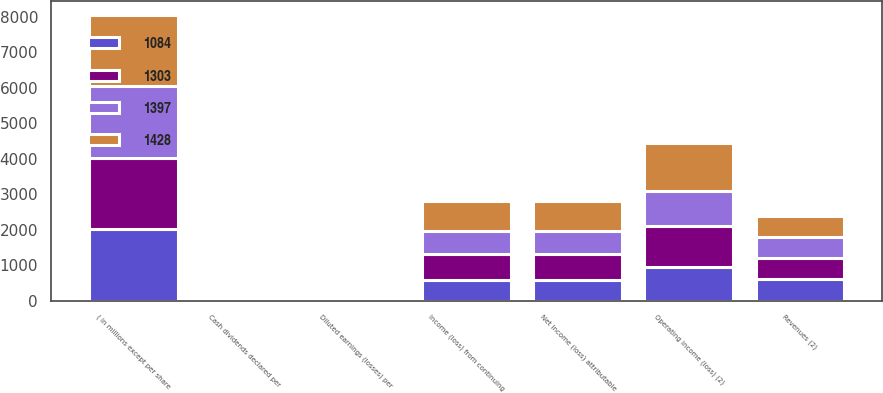Convert chart. <chart><loc_0><loc_0><loc_500><loc_500><stacked_bar_chart><ecel><fcel>( in millions except per share<fcel>Revenues (2)<fcel>Operating income (loss) (2)<fcel>Income (loss) from continuing<fcel>Net income (loss) attributable<fcel>Diluted earnings (losses) per<fcel>Cash dividends declared per<nl><fcel>1428<fcel>2015<fcel>598.5<fcel>1350<fcel>859<fcel>859<fcel>3.15<fcel>0.95<nl><fcel>1303<fcel>2014<fcel>598.5<fcel>1159<fcel>753<fcel>753<fcel>2.54<fcel>0.77<nl><fcel>1397<fcel>2013<fcel>598.5<fcel>988<fcel>626<fcel>626<fcel>2<fcel>0.64<nl><fcel>1084<fcel>2012<fcel>598.5<fcel>940<fcel>571<fcel>571<fcel>1.72<fcel>0.49<nl></chart> 